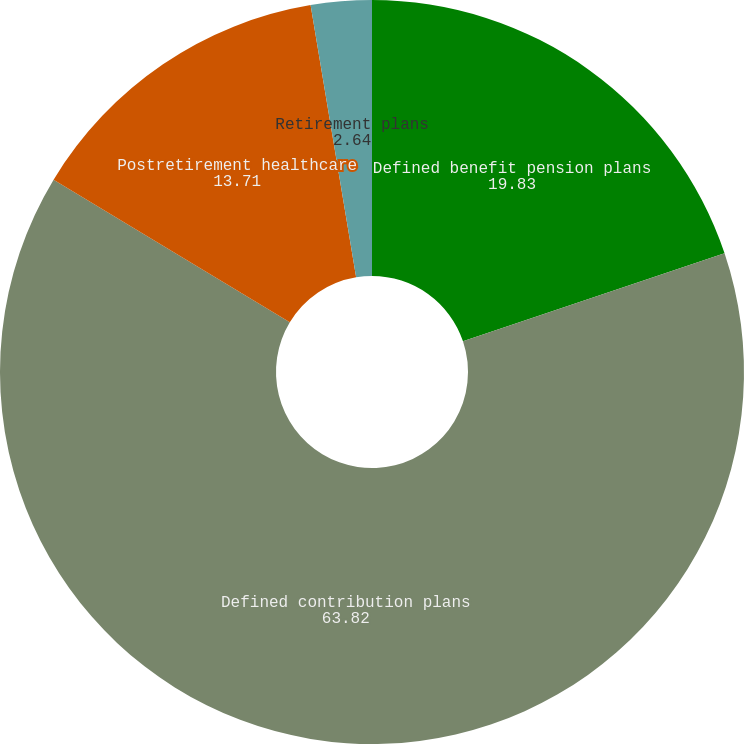<chart> <loc_0><loc_0><loc_500><loc_500><pie_chart><fcel>Defined benefit pension plans<fcel>Defined contribution plans<fcel>Postretirement healthcare<fcel>Retirement plans<nl><fcel>19.83%<fcel>63.82%<fcel>13.71%<fcel>2.64%<nl></chart> 